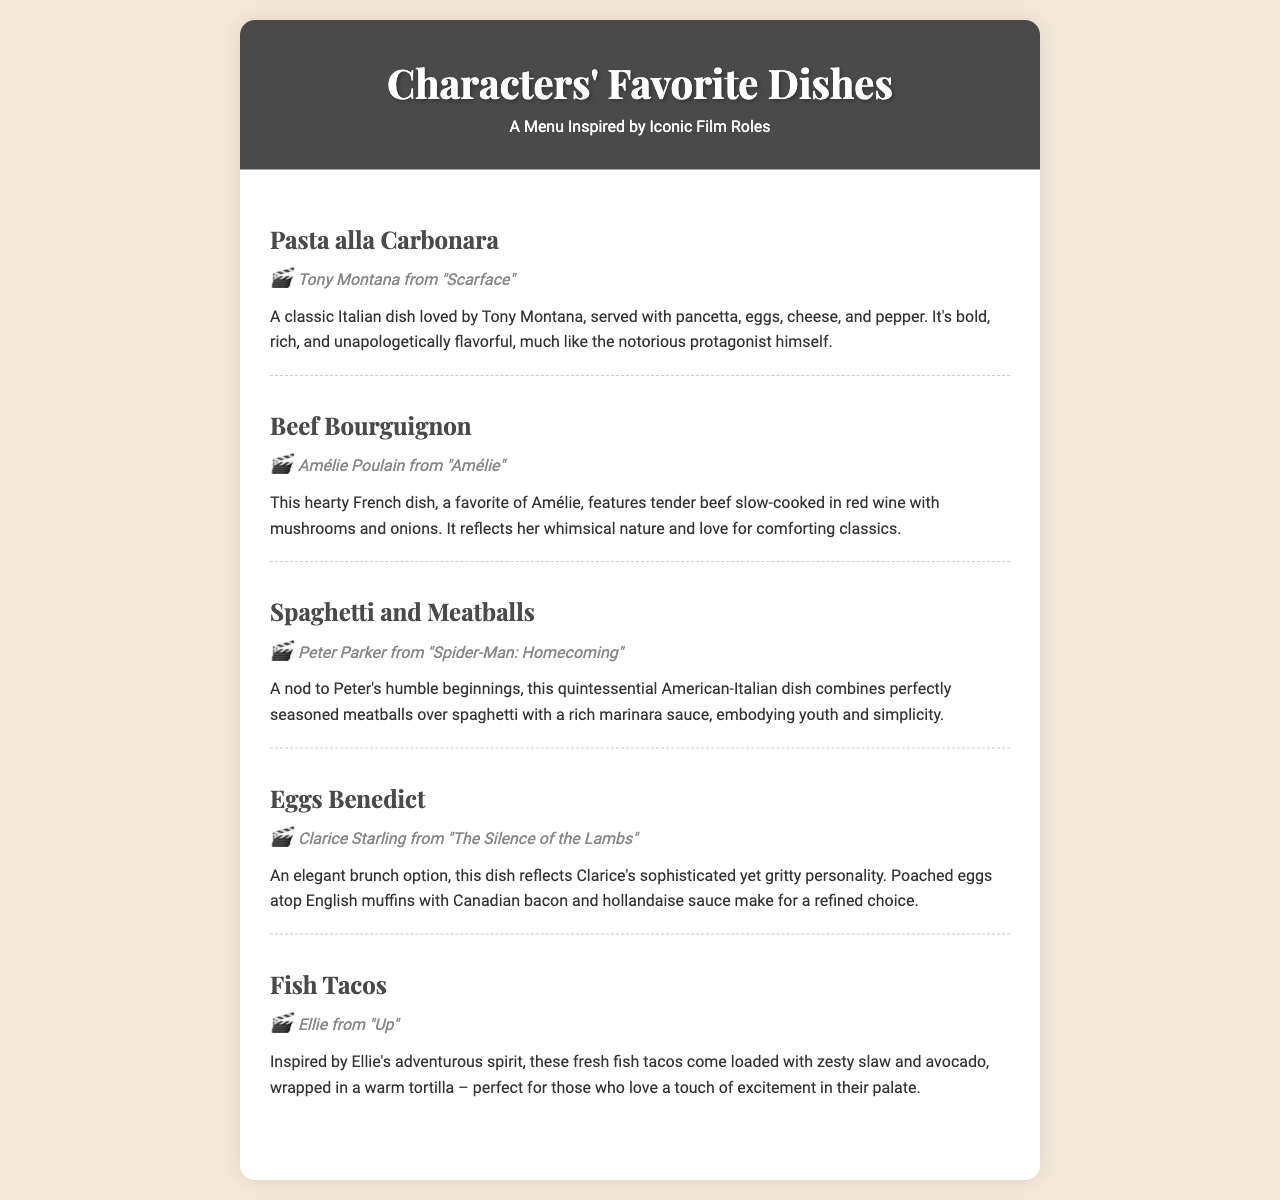What is the first dish listed on the menu? The first dish listed in the document is "Pasta alla Carbonara," as seen in the menu section.
Answer: Pasta alla Carbonara Who is associated with Beef Bourguignon? The dish Beef Bourguignon is associated with the character Amélie Poulain from "Amélie," according to the character information provided below the dish.
Answer: Amélie Poulain What type of cuisine is Spaghetti and Meatballs? Spaghetti and Meatballs is a quintessential American-Italian dish, as described in the menu section.
Answer: American-Italian Which character prefers Eggs Benedict? The character associated with Eggs Benedict is Clarice Starling from "The Silence of the Lambs," as detailed in the character info.
Answer: Clarice Starling What is Ellie’s favorite dish? Ellie's favorite dish, as presented in the document, is Fish Tacos, which reflects her adventurous spirit.
Answer: Fish Tacos What reflects Clarice Starling's personality? The dish that reflects Clarice Starling's personality is Eggs Benedict, described as elegant and refined in the document.
Answer: Eggs Benedict How many dishes are presented in the menu? The menu presents a total of five dishes, as counted from the list in the document.
Answer: Five What dish includes pancetta, eggs, cheese, and pepper? The dish that includes those ingredients is Pasta alla Carbonara, based on the description in the menu section.
Answer: Pasta alla Carbonara Which dish is inspired by a character's adventurous spirit? Fish Tacos are inspired by a character's adventurous spirit, specifically Ellie from "Up," per the description provided.
Answer: Fish Tacos 